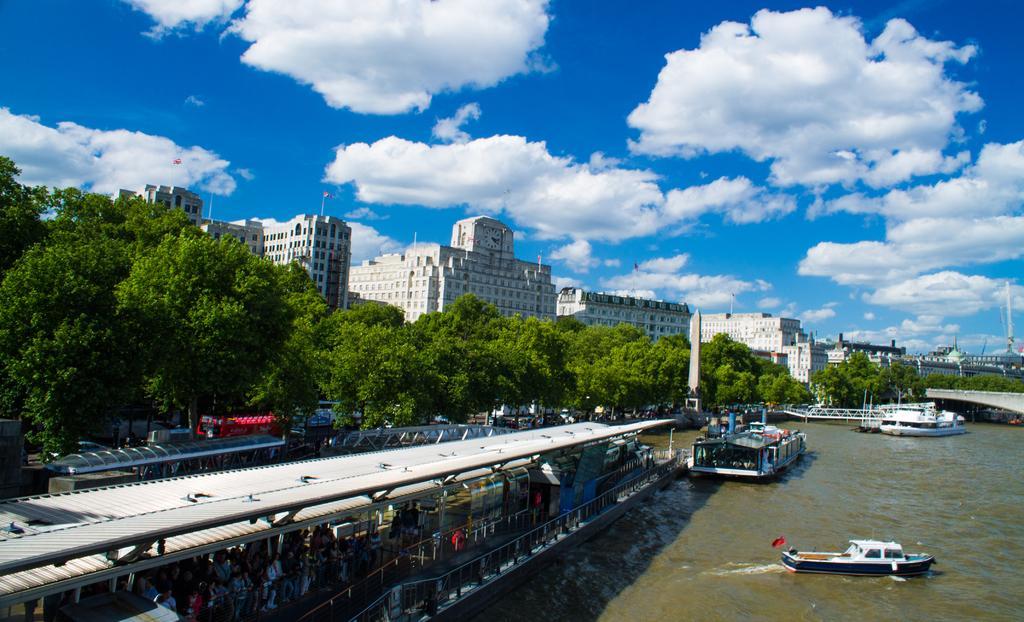Please provide a concise description of this image. There are few ships on water and there are few persons standing in the left corner and there are buildings and trees in the background. 